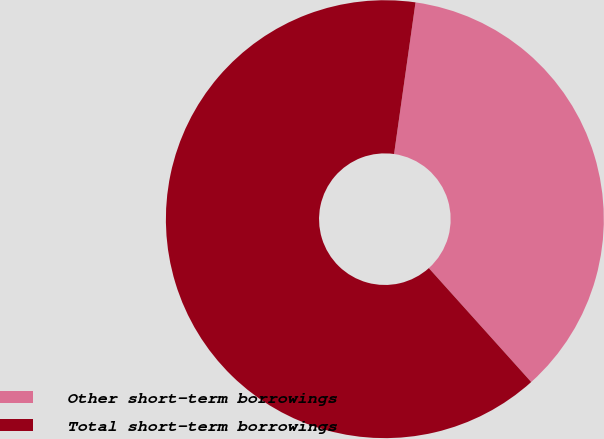Convert chart. <chart><loc_0><loc_0><loc_500><loc_500><pie_chart><fcel>Other short-term borrowings<fcel>Total short-term borrowings<nl><fcel>36.11%<fcel>63.89%<nl></chart> 